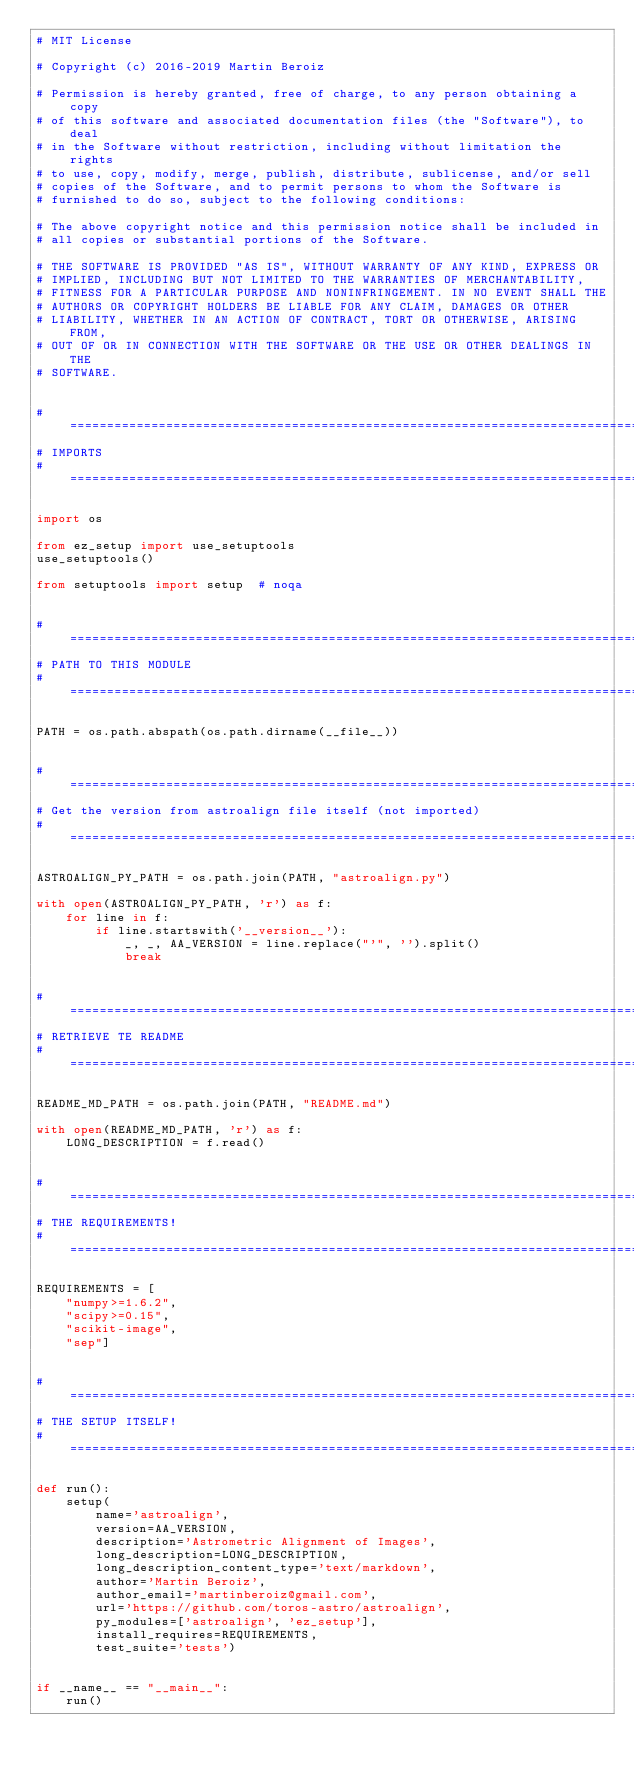Convert code to text. <code><loc_0><loc_0><loc_500><loc_500><_Python_># MIT License

# Copyright (c) 2016-2019 Martin Beroiz

# Permission is hereby granted, free of charge, to any person obtaining a copy
# of this software and associated documentation files (the "Software"), to deal
# in the Software without restriction, including without limitation the rights
# to use, copy, modify, merge, publish, distribute, sublicense, and/or sell
# copies of the Software, and to permit persons to whom the Software is
# furnished to do so, subject to the following conditions:

# The above copyright notice and this permission notice shall be included in
# all copies or substantial portions of the Software.

# THE SOFTWARE IS PROVIDED "AS IS", WITHOUT WARRANTY OF ANY KIND, EXPRESS OR
# IMPLIED, INCLUDING BUT NOT LIMITED TO THE WARRANTIES OF MERCHANTABILITY,
# FITNESS FOR A PARTICULAR PURPOSE AND NONINFRINGEMENT. IN NO EVENT SHALL THE
# AUTHORS OR COPYRIGHT HOLDERS BE LIABLE FOR ANY CLAIM, DAMAGES OR OTHER
# LIABILITY, WHETHER IN AN ACTION OF CONTRACT, TORT OR OTHERWISE, ARISING FROM,
# OUT OF OR IN CONNECTION WITH THE SOFTWARE OR THE USE OR OTHER DEALINGS IN THE
# SOFTWARE.


# =============================================================================
# IMPORTS
# =============================================================================

import os

from ez_setup import use_setuptools
use_setuptools()

from setuptools import setup  # noqa


# =============================================================================
# PATH TO THIS MODULE
# =============================================================================

PATH = os.path.abspath(os.path.dirname(__file__))


# =============================================================================
# Get the version from astroalign file itself (not imported)
# =============================================================================

ASTROALIGN_PY_PATH = os.path.join(PATH, "astroalign.py")

with open(ASTROALIGN_PY_PATH, 'r') as f:
    for line in f:
        if line.startswith('__version__'):
            _, _, AA_VERSION = line.replace("'", '').split()
            break


# =============================================================================
# RETRIEVE TE README
# =============================================================================

README_MD_PATH = os.path.join(PATH, "README.md")

with open(README_MD_PATH, 'r') as f:
    LONG_DESCRIPTION = f.read()


# =============================================================================
# THE REQUIREMENTS!
# =============================================================================

REQUIREMENTS = [
    "numpy>=1.6.2",
    "scipy>=0.15",
    "scikit-image",
    "sep"]


# =============================================================================
# THE SETUP ITSELF!
# =============================================================================

def run():
    setup(
        name='astroalign',
        version=AA_VERSION,
        description='Astrometric Alignment of Images',
        long_description=LONG_DESCRIPTION,
        long_description_content_type='text/markdown',
        author='Martin Beroiz',
        author_email='martinberoiz@gmail.com',
        url='https://github.com/toros-astro/astroalign',
        py_modules=['astroalign', 'ez_setup'],
        install_requires=REQUIREMENTS,
        test_suite='tests')


if __name__ == "__main__":
    run()
</code> 